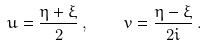<formula> <loc_0><loc_0><loc_500><loc_500>u = \frac { \eta + \xi } { 2 } \, , \quad v = \frac { \eta - \xi } { 2 i } \, .</formula> 